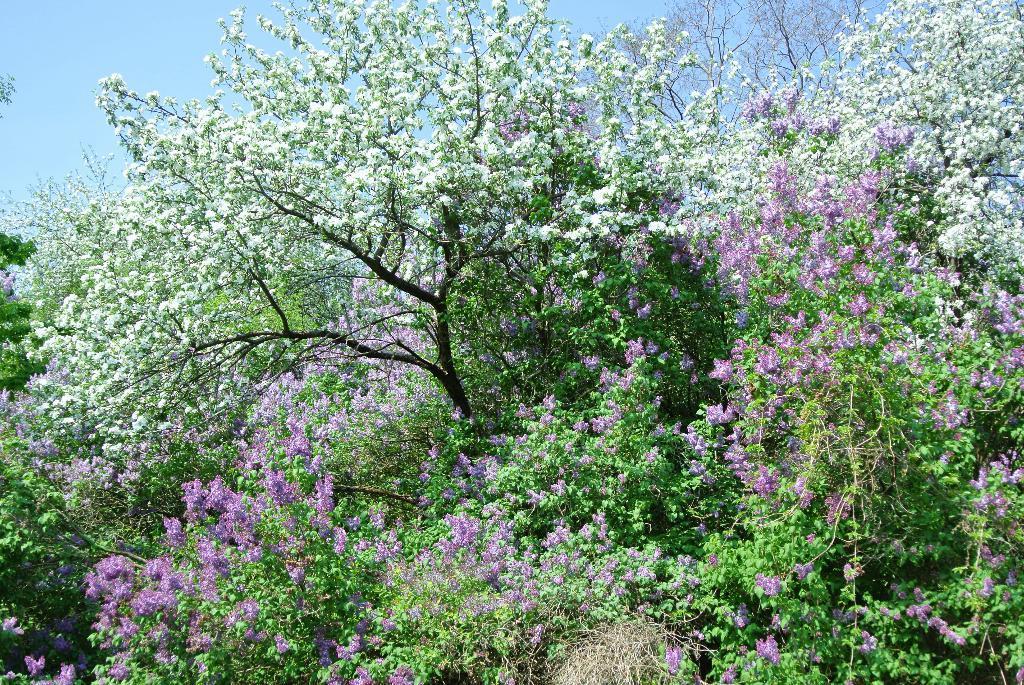Please provide a concise description of this image. In the image there are beautiful flowers to the branches of the trees. 